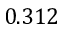<formula> <loc_0><loc_0><loc_500><loc_500>0 . 3 1 2</formula> 